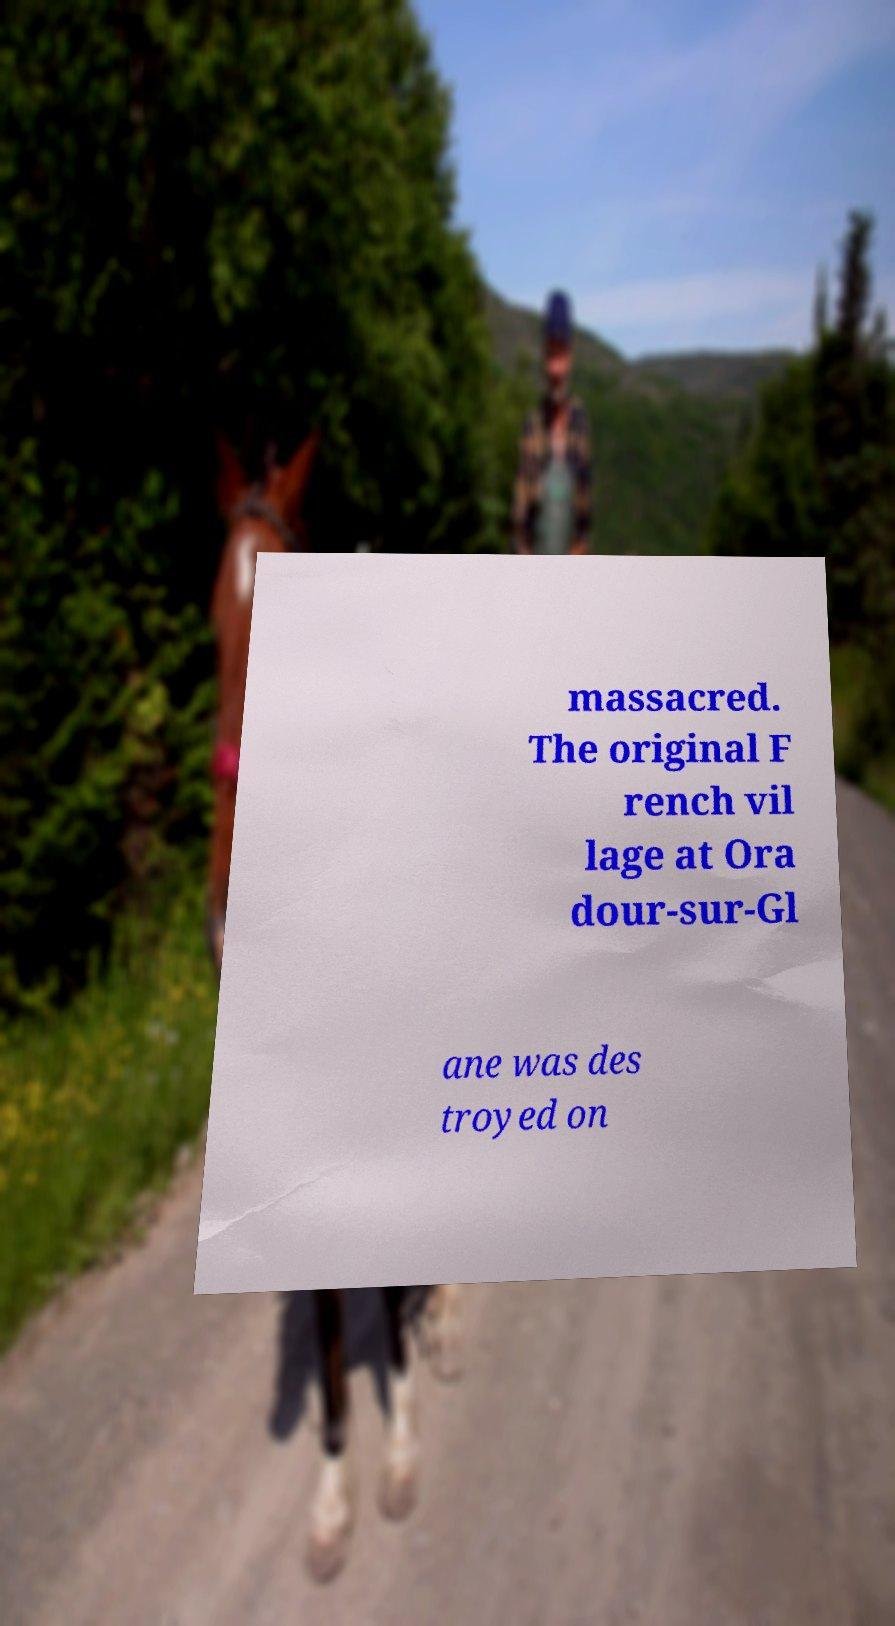There's text embedded in this image that I need extracted. Can you transcribe it verbatim? massacred. The original F rench vil lage at Ora dour-sur-Gl ane was des troyed on 